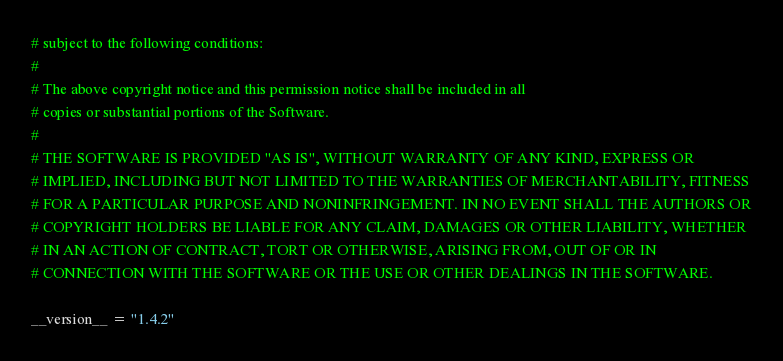<code> <loc_0><loc_0><loc_500><loc_500><_Python_># subject to the following conditions:
#
# The above copyright notice and this permission notice shall be included in all
# copies or substantial portions of the Software.
#
# THE SOFTWARE IS PROVIDED "AS IS", WITHOUT WARRANTY OF ANY KIND, EXPRESS OR
# IMPLIED, INCLUDING BUT NOT LIMITED TO THE WARRANTIES OF MERCHANTABILITY, FITNESS
# FOR A PARTICULAR PURPOSE AND NONINFRINGEMENT. IN NO EVENT SHALL THE AUTHORS OR
# COPYRIGHT HOLDERS BE LIABLE FOR ANY CLAIM, DAMAGES OR OTHER LIABILITY, WHETHER
# IN AN ACTION OF CONTRACT, TORT OR OTHERWISE, ARISING FROM, OUT OF OR IN
# CONNECTION WITH THE SOFTWARE OR THE USE OR OTHER DEALINGS IN THE SOFTWARE.

__version__ = "1.4.2"
</code> 